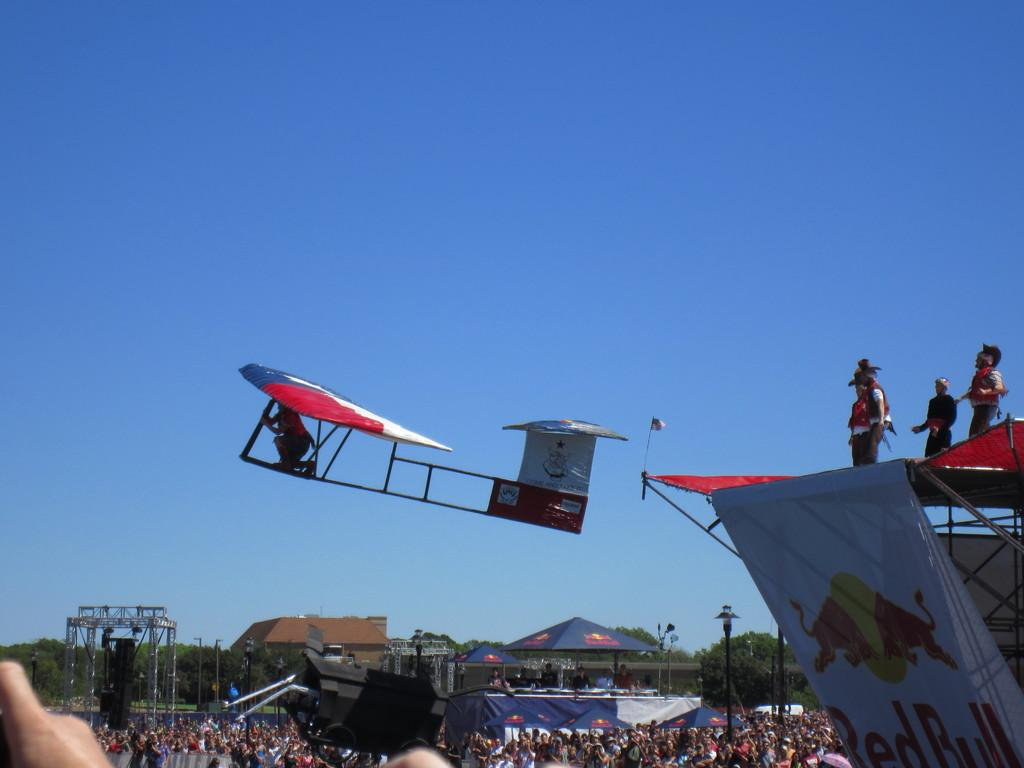<image>
Offer a succinct explanation of the picture presented. A person in a flying machine jumps off the stage in Red Bull human flying machine contest. 